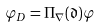Convert formula to latex. <formula><loc_0><loc_0><loc_500><loc_500>\varphi _ { D } = \Pi _ { \nabla } ( \mathfrak { d } ) \varphi</formula> 